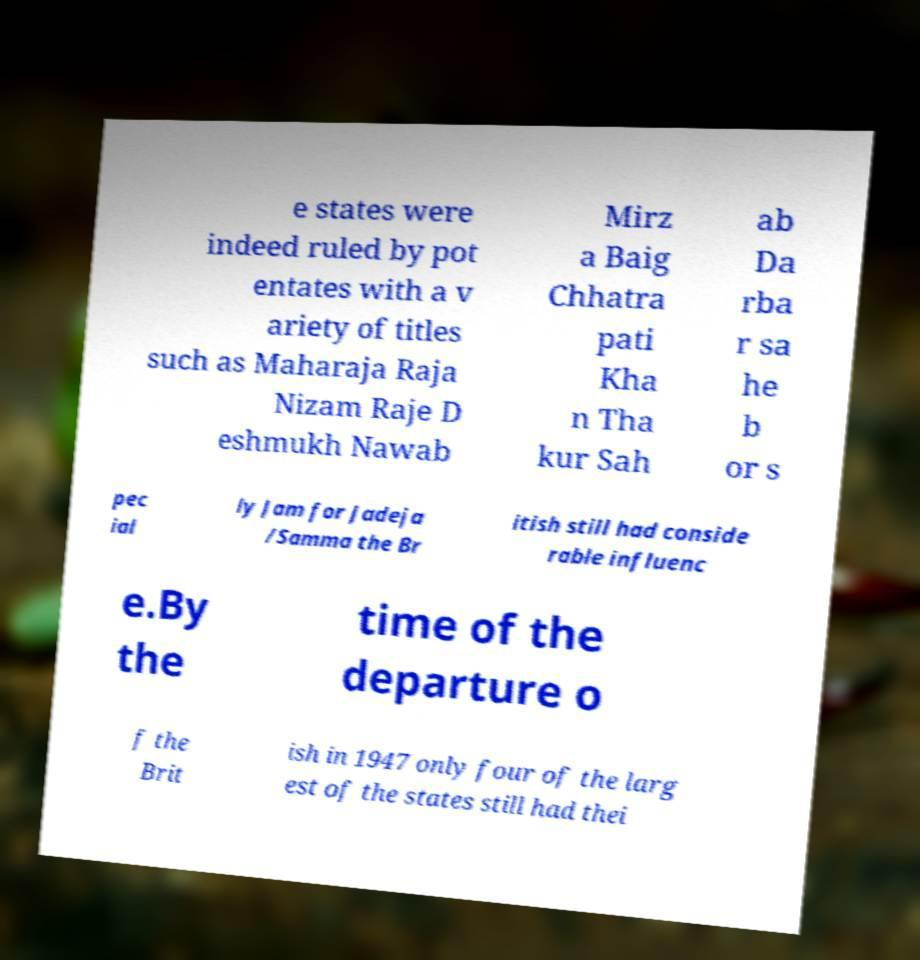Could you assist in decoding the text presented in this image and type it out clearly? e states were indeed ruled by pot entates with a v ariety of titles such as Maharaja Raja Nizam Raje D eshmukh Nawab Mirz a Baig Chhatra pati Kha n Tha kur Sah ab Da rba r sa he b or s pec ial ly Jam for Jadeja /Samma the Br itish still had conside rable influenc e.By the time of the departure o f the Brit ish in 1947 only four of the larg est of the states still had thei 